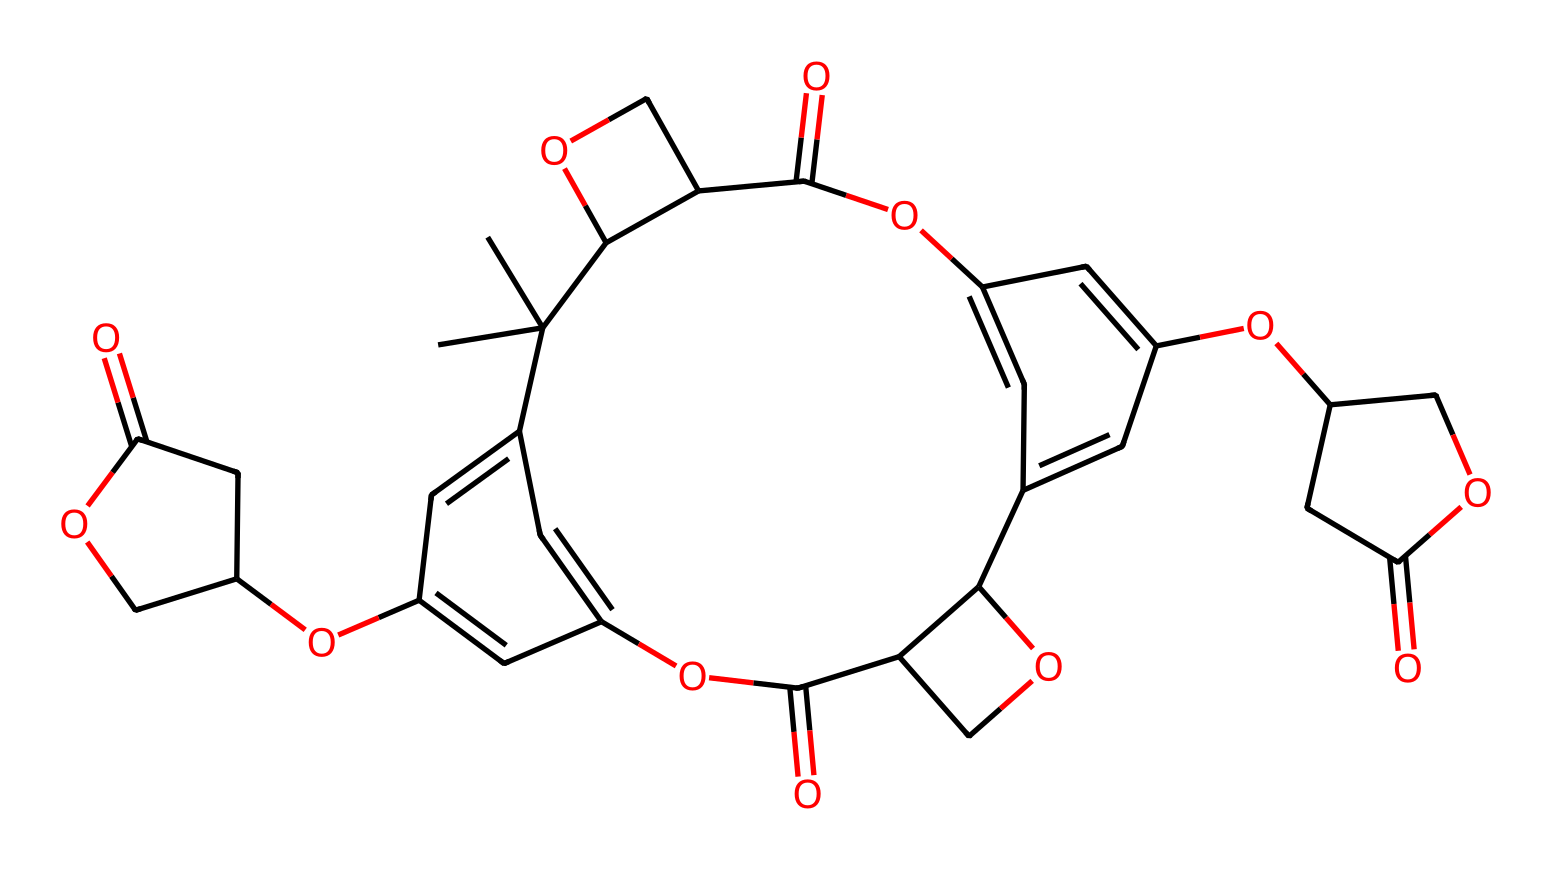What is the basic functional group present in SU-8? The structure contains multiple ether (–O–) linkages, which are characteristic of polyethers.
Answer: ether How many rings are present in the chemical structure of SU-8? By analyzing the structure, there are three cyclic (ring) structures visible, specifically indicating the presence of aromatic characteristics.
Answer: three What type of polymerization process does SU-8 undergo? Given that SU-8 is a negative photoresist, it undergoes cross-linking polymerization upon exposure to UV light and subsequent development.
Answer: cross-linking What is the average molecular weight if represented by a specific range? The structure's complexity and the presence of multiple repeating units suggest a molecular weight range, typically estimated at around one thousand to five thousand grams per mole depending on the polymer chain length.
Answer: one thousand to five thousand Which application is SU-8 primarily used for in the field of microsystems? SU-8 is predominantly used in microfluidics and biosensor applications due to its excellent resolution and stability properties when patterned.
Answer: microfluidics and biosensors 